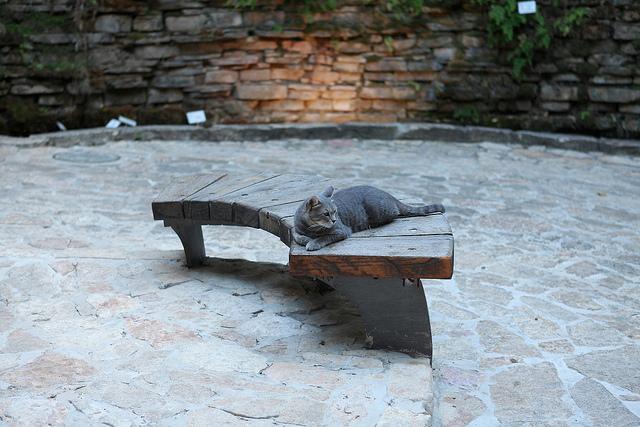How many animals are there?
Be succinct. 1. What is the ground made of?
Give a very brief answer. Stone. What is the animal doing?
Give a very brief answer. Sitting. 